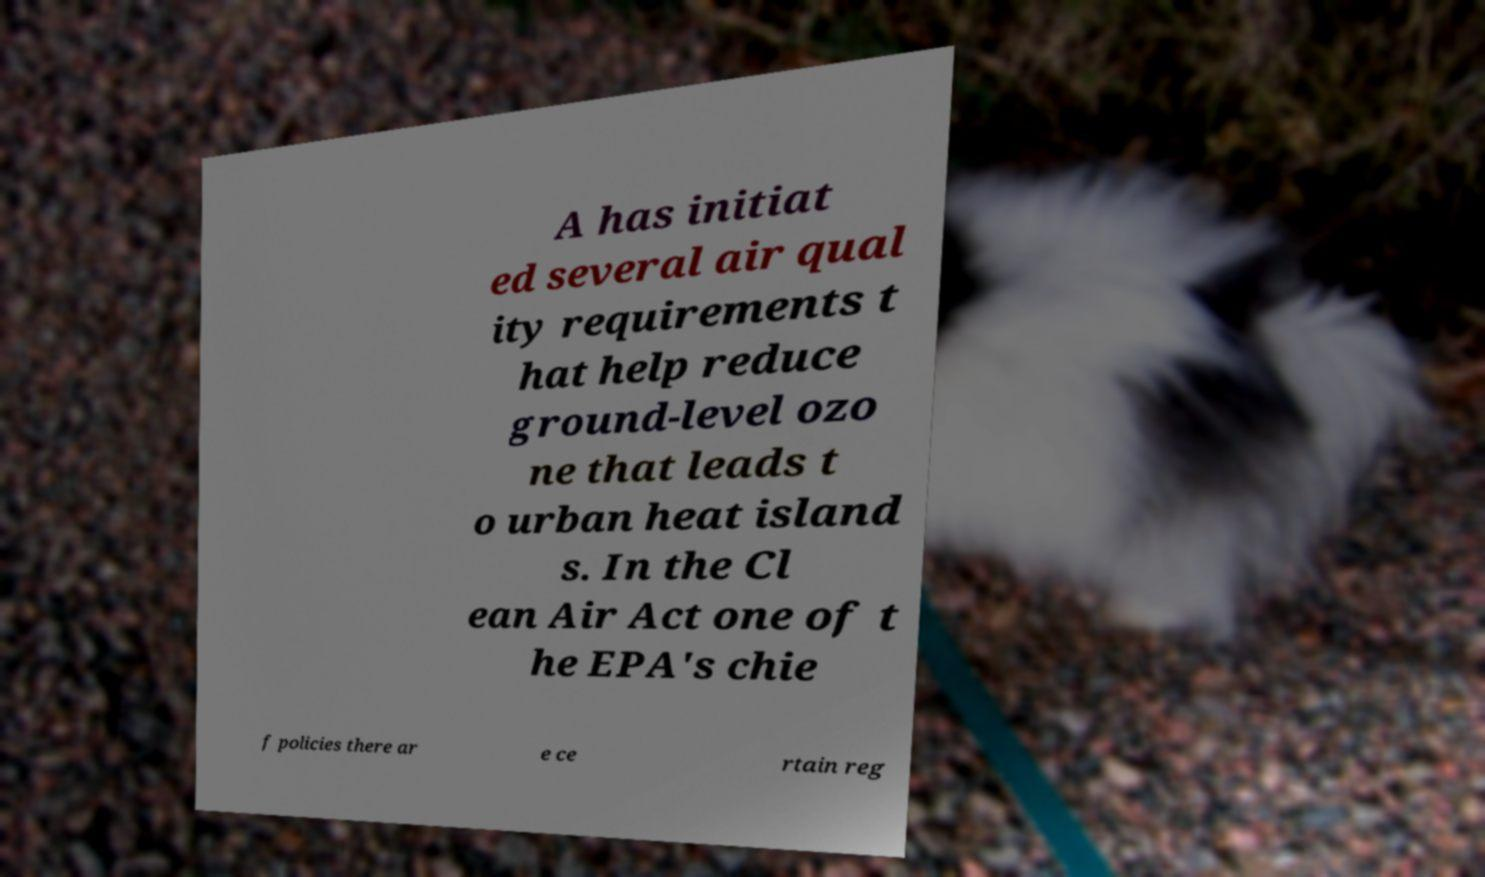Can you accurately transcribe the text from the provided image for me? A has initiat ed several air qual ity requirements t hat help reduce ground-level ozo ne that leads t o urban heat island s. In the Cl ean Air Act one of t he EPA's chie f policies there ar e ce rtain reg 